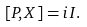Convert formula to latex. <formula><loc_0><loc_0><loc_500><loc_500>[ P , X ] = i I .</formula> 